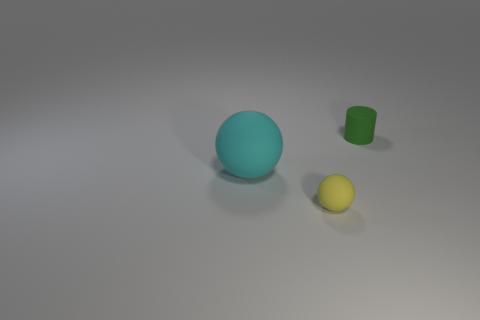There is a small yellow rubber object; is its shape the same as the rubber object on the left side of the small yellow rubber thing?
Offer a terse response. Yes. What is the cyan sphere that is to the left of the small thing that is in front of the object that is to the right of the yellow matte ball made of?
Offer a terse response. Rubber. Are there any green objects of the same size as the yellow thing?
Provide a succinct answer. Yes. There is a cyan sphere that is the same material as the green cylinder; what is its size?
Keep it short and to the point. Large. The large cyan matte thing is what shape?
Your answer should be very brief. Sphere. Do the big cyan object and the tiny thing in front of the cyan rubber ball have the same material?
Give a very brief answer. Yes. What number of objects are either tiny blue metal things or cyan spheres?
Your response must be concise. 1. Are any yellow objects visible?
Your answer should be very brief. Yes. What is the shape of the thing on the left side of the small object that is to the left of the green rubber thing?
Your answer should be compact. Sphere. What number of things are either tiny matte things to the left of the small green object or objects to the right of the tiny yellow matte thing?
Make the answer very short. 2. 